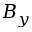<formula> <loc_0><loc_0><loc_500><loc_500>B _ { y }</formula> 